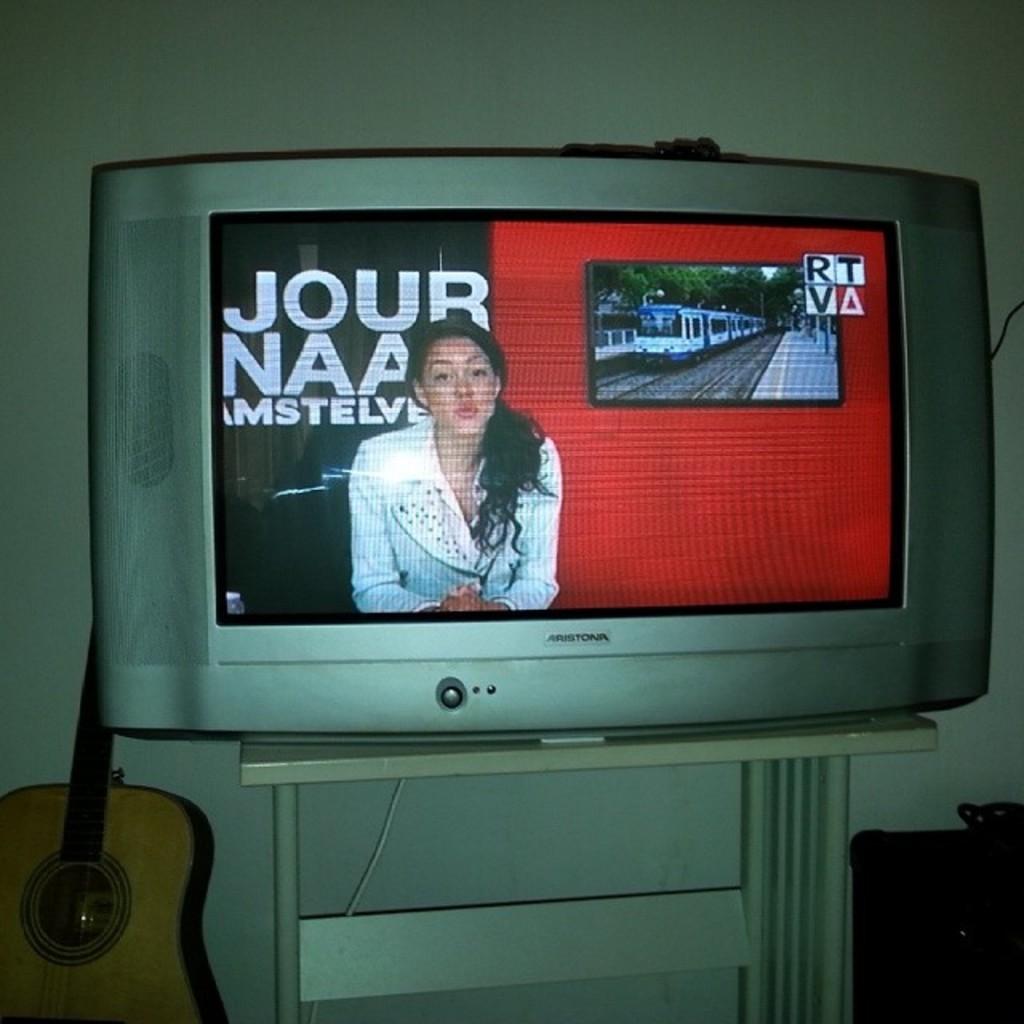What is the brand of tv?
Offer a very short reply. Aristona. 